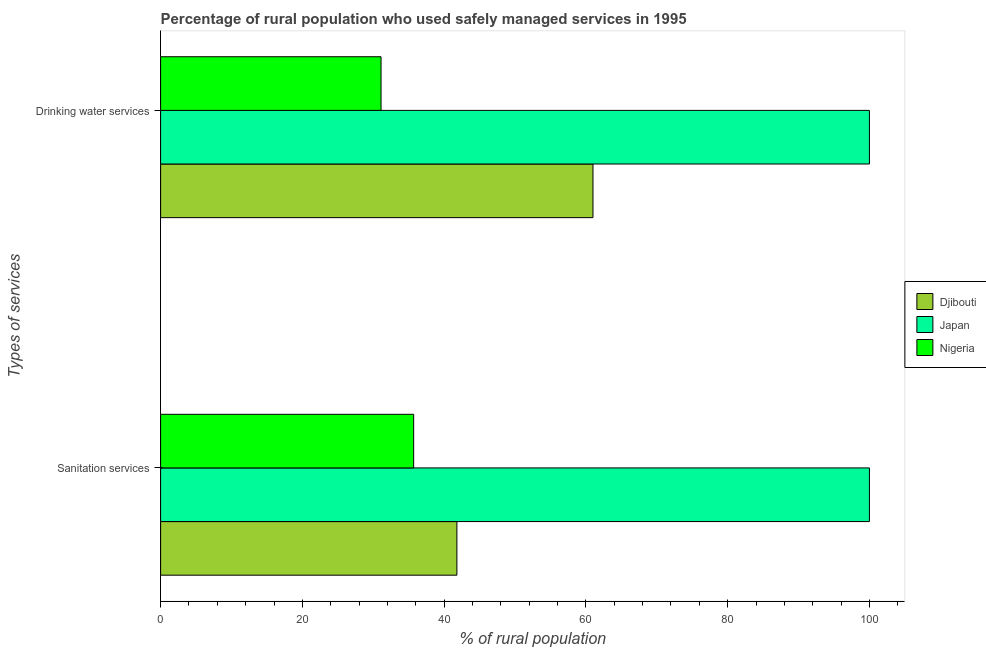Are the number of bars on each tick of the Y-axis equal?
Your answer should be compact. Yes. What is the label of the 1st group of bars from the top?
Provide a succinct answer. Drinking water services. Across all countries, what is the maximum percentage of rural population who used drinking water services?
Ensure brevity in your answer.  100. Across all countries, what is the minimum percentage of rural population who used sanitation services?
Keep it short and to the point. 35.7. In which country was the percentage of rural population who used drinking water services minimum?
Your answer should be compact. Nigeria. What is the total percentage of rural population who used drinking water services in the graph?
Make the answer very short. 192.1. What is the difference between the percentage of rural population who used sanitation services in Djibouti and that in Japan?
Give a very brief answer. -58.2. What is the average percentage of rural population who used sanitation services per country?
Provide a succinct answer. 59.17. What is the difference between the percentage of rural population who used sanitation services and percentage of rural population who used drinking water services in Japan?
Your answer should be very brief. 0. What is the ratio of the percentage of rural population who used drinking water services in Japan to that in Djibouti?
Provide a succinct answer. 1.64. In how many countries, is the percentage of rural population who used drinking water services greater than the average percentage of rural population who used drinking water services taken over all countries?
Provide a succinct answer. 1. What does the 2nd bar from the top in Sanitation services represents?
Your response must be concise. Japan. What does the 1st bar from the bottom in Sanitation services represents?
Give a very brief answer. Djibouti. How many countries are there in the graph?
Give a very brief answer. 3. What is the difference between two consecutive major ticks on the X-axis?
Offer a terse response. 20. Where does the legend appear in the graph?
Give a very brief answer. Center right. How many legend labels are there?
Provide a short and direct response. 3. How are the legend labels stacked?
Offer a very short reply. Vertical. What is the title of the graph?
Offer a very short reply. Percentage of rural population who used safely managed services in 1995. What is the label or title of the X-axis?
Provide a short and direct response. % of rural population. What is the label or title of the Y-axis?
Your response must be concise. Types of services. What is the % of rural population in Djibouti in Sanitation services?
Provide a short and direct response. 41.8. What is the % of rural population in Japan in Sanitation services?
Make the answer very short. 100. What is the % of rural population of Nigeria in Sanitation services?
Provide a succinct answer. 35.7. What is the % of rural population of Nigeria in Drinking water services?
Ensure brevity in your answer.  31.1. Across all Types of services, what is the maximum % of rural population of Japan?
Provide a short and direct response. 100. Across all Types of services, what is the maximum % of rural population of Nigeria?
Your answer should be very brief. 35.7. Across all Types of services, what is the minimum % of rural population in Djibouti?
Make the answer very short. 41.8. Across all Types of services, what is the minimum % of rural population of Nigeria?
Make the answer very short. 31.1. What is the total % of rural population of Djibouti in the graph?
Make the answer very short. 102.8. What is the total % of rural population in Nigeria in the graph?
Give a very brief answer. 66.8. What is the difference between the % of rural population in Djibouti in Sanitation services and that in Drinking water services?
Your response must be concise. -19.2. What is the difference between the % of rural population of Djibouti in Sanitation services and the % of rural population of Japan in Drinking water services?
Your response must be concise. -58.2. What is the difference between the % of rural population of Japan in Sanitation services and the % of rural population of Nigeria in Drinking water services?
Keep it short and to the point. 68.9. What is the average % of rural population in Djibouti per Types of services?
Provide a succinct answer. 51.4. What is the average % of rural population of Nigeria per Types of services?
Your answer should be compact. 33.4. What is the difference between the % of rural population in Djibouti and % of rural population in Japan in Sanitation services?
Provide a short and direct response. -58.2. What is the difference between the % of rural population in Djibouti and % of rural population in Nigeria in Sanitation services?
Your answer should be very brief. 6.1. What is the difference between the % of rural population of Japan and % of rural population of Nigeria in Sanitation services?
Your answer should be very brief. 64.3. What is the difference between the % of rural population of Djibouti and % of rural population of Japan in Drinking water services?
Keep it short and to the point. -39. What is the difference between the % of rural population in Djibouti and % of rural population in Nigeria in Drinking water services?
Provide a succinct answer. 29.9. What is the difference between the % of rural population in Japan and % of rural population in Nigeria in Drinking water services?
Your answer should be very brief. 68.9. What is the ratio of the % of rural population of Djibouti in Sanitation services to that in Drinking water services?
Provide a short and direct response. 0.69. What is the ratio of the % of rural population of Japan in Sanitation services to that in Drinking water services?
Your response must be concise. 1. What is the ratio of the % of rural population in Nigeria in Sanitation services to that in Drinking water services?
Make the answer very short. 1.15. What is the difference between the highest and the second highest % of rural population of Japan?
Your response must be concise. 0. What is the difference between the highest and the second highest % of rural population of Nigeria?
Provide a short and direct response. 4.6. What is the difference between the highest and the lowest % of rural population of Djibouti?
Your answer should be very brief. 19.2. What is the difference between the highest and the lowest % of rural population of Japan?
Your answer should be compact. 0. What is the difference between the highest and the lowest % of rural population in Nigeria?
Provide a succinct answer. 4.6. 